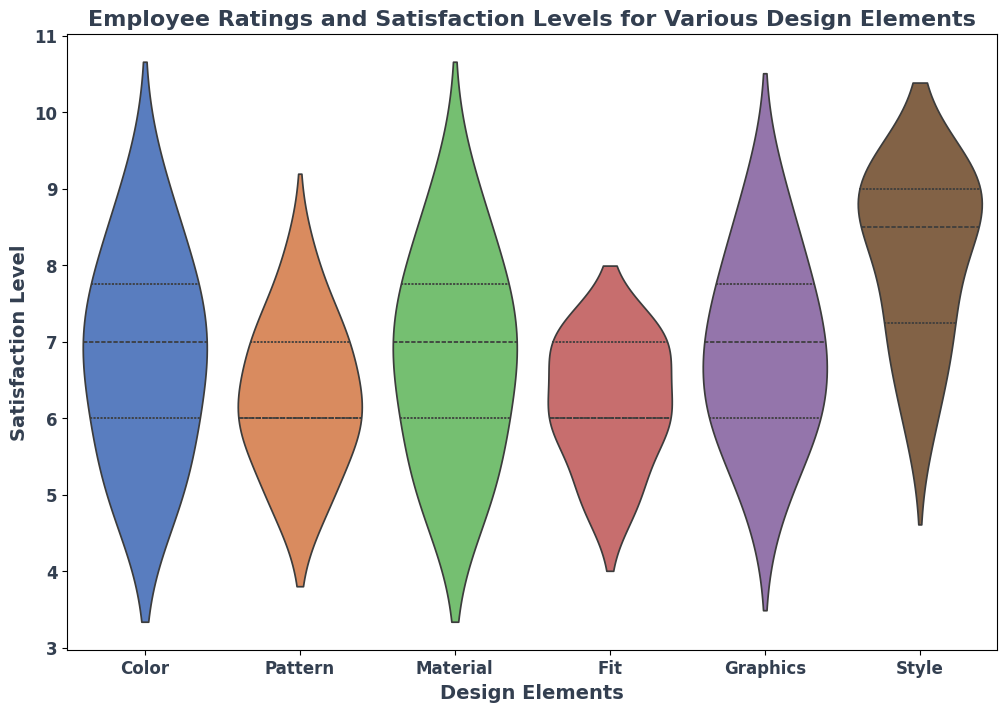Which design element shows the highest median satisfaction level? The median point is typically represented by a line within the violin plot. By observing the median lines, Style appears to have the highest median satisfaction level.
Answer: Style Which design element has the widest spread of satisfaction levels? The spread can be determined by looking at the width of the violin plot. Material shows a wider spread compared to others, indicating a broader range of satisfaction levels.
Answer: Material Comparing Color and Pattern, which design element shows a higher median satisfaction level? By referencing the median lines within the violin plots for Color and Pattern, it is clear that Color has a higher median satisfaction level.
Answer: Color Which design elements have overlapping satisfaction level distributions? By examining the overlapping regions of the violin plots, Color and Material, as well as Fit and Pattern, show overlapping distributions.
Answer: Color and Material, Fit and Pattern Are there any design elements where the minimum and maximum satisfaction levels are more than three units apart? To find this, compare the highest and lowest points of each violin plot. Graphics shows satisfaction levels from 5 to 9, which is a 4-unit difference.
Answer: Graphics What is the approximate range of satisfaction levels for Fit? By inspecting the extent of the Fit violin plot on the vertical axis, the range appears to be from 5 to 7.
Answer: 5 to 7 Which design element seems to have the most consistent satisfaction levels, indicated by the narrowest plot? A narrow plot implies less variability in satisfaction levels. Fit has the narrowest width, suggesting the most consistency.
Answer: Fit Does any design element have a bimodal distribution, indicated by multiple peaks in the violin plot? Look for violin plots with more than one peak. The Color design element shows a bimodal distribution, indicated by two prominent peaks.
Answer: Color 